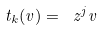<formula> <loc_0><loc_0><loc_500><loc_500>t _ { k } ( v ) = \ z ^ { j } v</formula> 